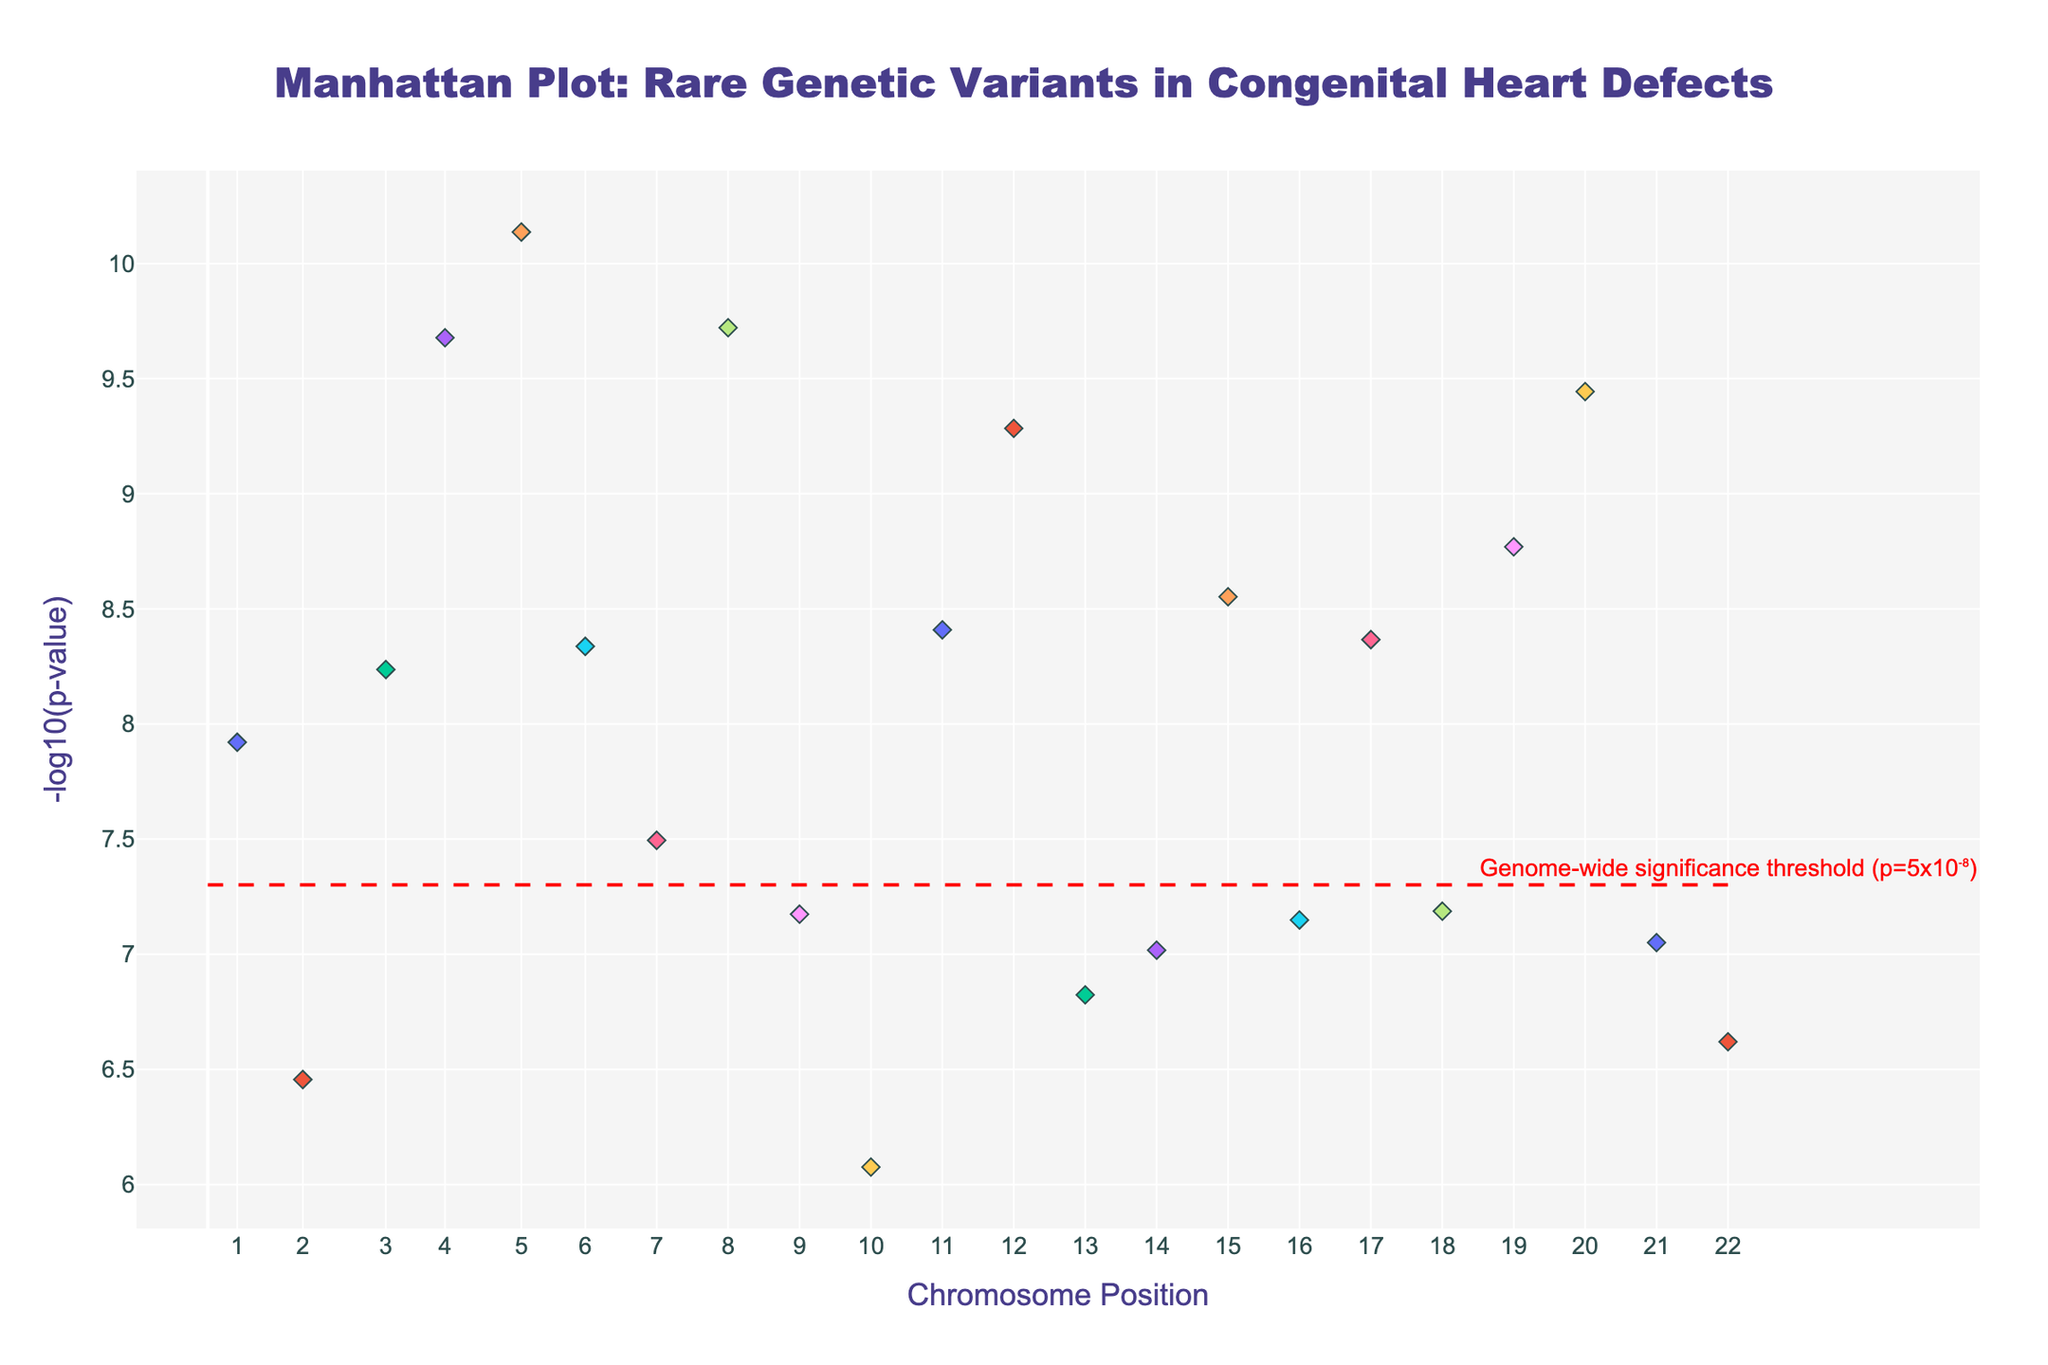What's the title of the figure? The title of the figure is prominently displayed at the top center.
Answer: Manhattan Plot: Rare Genetic Variants in Congenital Heart Defects What is shown on the x-axis? The x-axis represents the chromosome positions, with ticks labeled by chromosome number.
Answer: Chromosome Position What is the y-axis title? The y-axis title is visible on the left side of the figure.
Answer: -log10(p-value) Which gene has the lowest p-value in the plot? To determine the gene with the lowest p-value, look for the highest point on the y-axis because -log10(p-value) is plotted. The gene associated with this point is HAND2.
Answer: HAND2 Which chromosomes have multiple genes listed? To find chromosomes with multiple genes listed, observe the color-coded scatter points for overlaps in their data positions within the same chromosome grouping. Chromosomes 1, 4, 9, 19, and 20 each have more than one gene listed.
Answer: Chromosome 4 What is the genome-wide significance threshold line indicating? The horizontal dashed red line across the plot is labeled with the significance threshold. This line indicates the p-value threshold (5x10⁻⁸) for statistical significance.
Answer: p=5x10⁻⁸ Which gene is associated with the highest variant on Chromosome 17? On the plot, hover over the data point that represents Chromosome 17 and find the y-coordinate corresponding to the highest -log10(p-value). The gene associated is ACTC1, as it has the highest y-value.
Answer: ACTC1 How many genes have a p-value less than 7.3e-11? Convert the p-value to -log10(p-value) and count the points above this threshold. HAND2, NKX2-5, and MYH7 have p-values less than 7.3e-11.
Answer: 3 genes Which chromosome shows the gene with the second highest -log10(p-value)? To find the second highest point, observe the plot for the second highest -log10(p-value), which corresponds to a gene on Chromosome 5 (NKX2-5).
Answer: Chromosome 5 How does the p-value of the variant in GATA4 compare with that in GATA5? Compare the y-values for GATA4 and GATA5. GATA4 has a -log10(p-value) higher than GATA5, indicating GATA4 has a lower p-value.
Answer: GATA4 < GATA5 